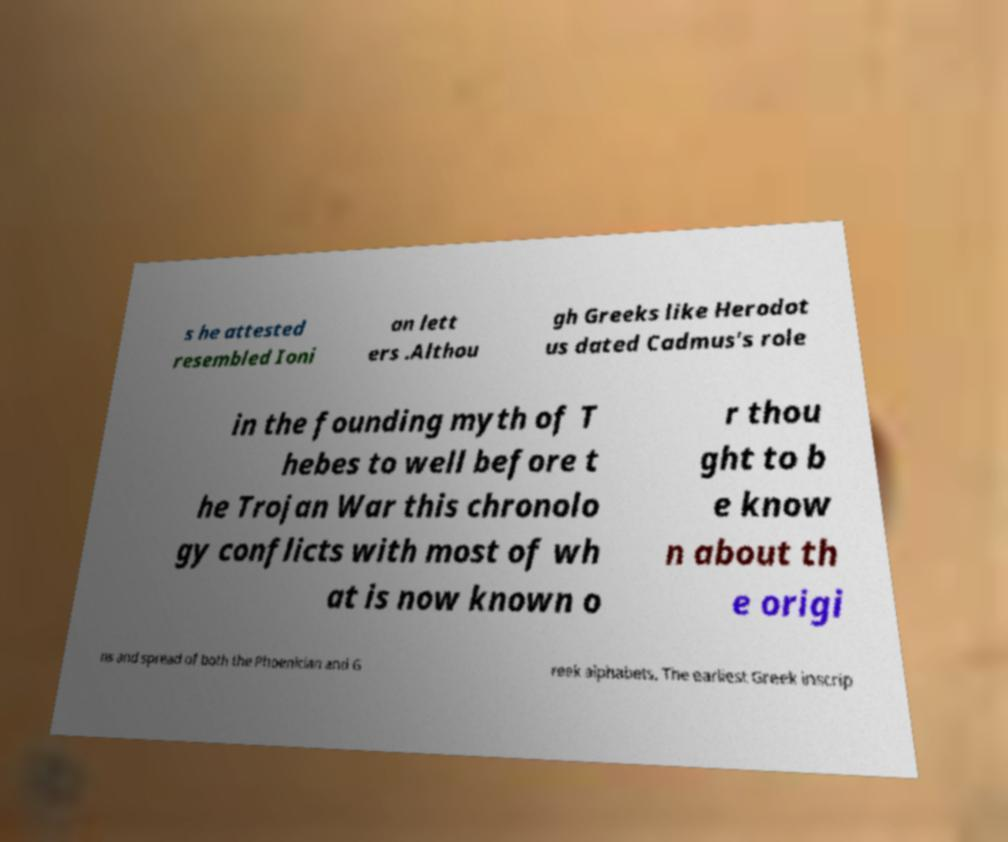Could you assist in decoding the text presented in this image and type it out clearly? s he attested resembled Ioni an lett ers .Althou gh Greeks like Herodot us dated Cadmus's role in the founding myth of T hebes to well before t he Trojan War this chronolo gy conflicts with most of wh at is now known o r thou ght to b e know n about th e origi ns and spread of both the Phoenician and G reek alphabets. The earliest Greek inscrip 